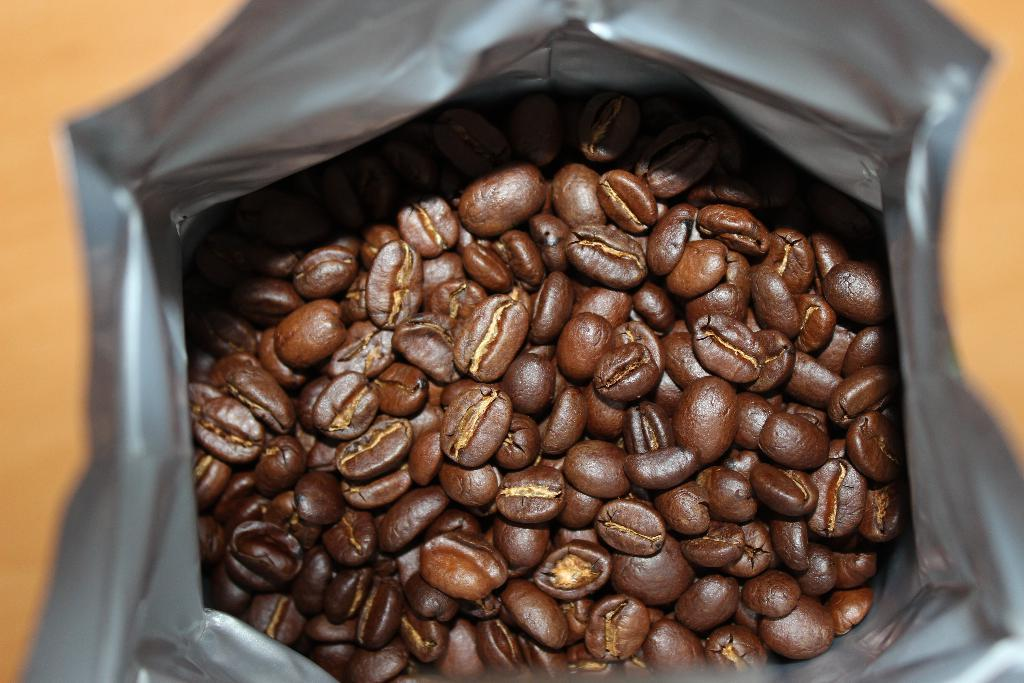What type of food is present in the image? There are beans in the image. What color are the beans? The beans are brown in color. How are the beans contained in the image? The beans are in a grey color cover. Can you describe the background of the image? The background of the image is blurred. How much money is hidden inside the beans in the image? There is no money hidden inside the beans in the image. Is there a prison visible in the background of the image? There is no prison visible in the image; the background is blurred. 